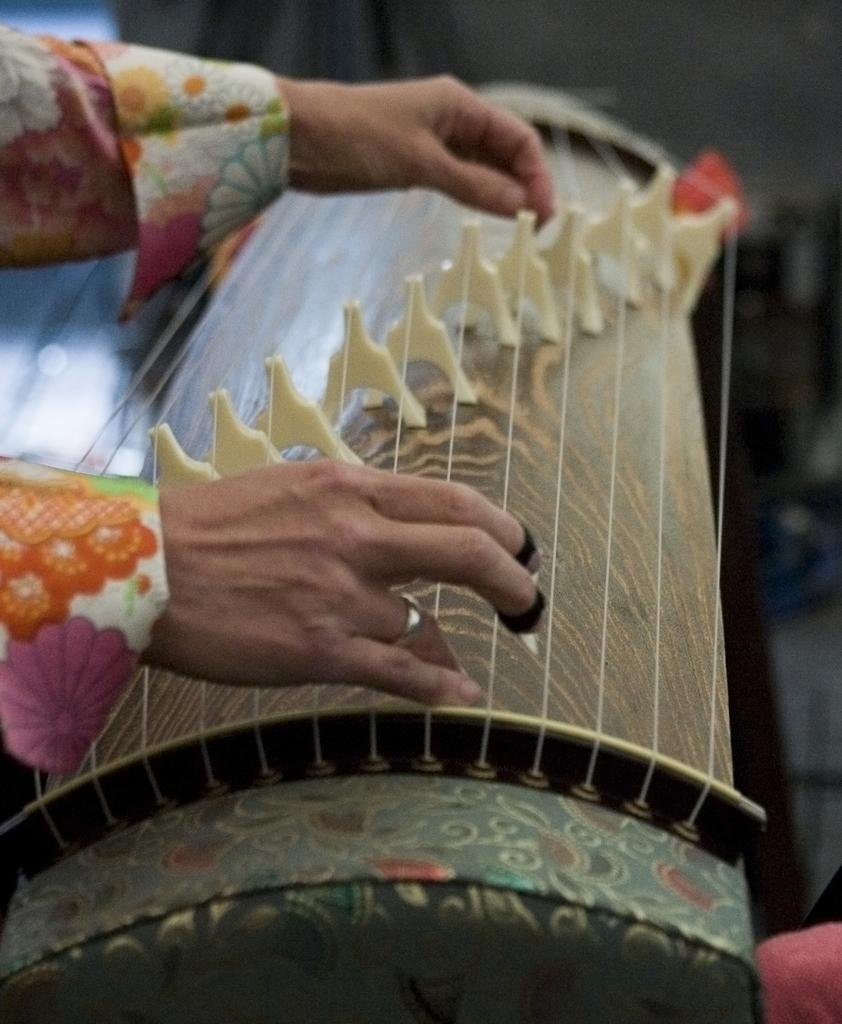What body part is visible in the image? Human hands are visible in the image. What are the hands wearing? The hands are wearing a finger ring. What else can be seen in the image besides the hands? Clothes and a musical instrument are present in the image. How many cattle are visible in the image? There are no cattle present in the image. What type of pen is being used to write on the musical instrument? There is no pen visible in the image, and the musical instrument is not being written on. 